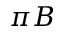Convert formula to latex. <formula><loc_0><loc_0><loc_500><loc_500>\pi B</formula> 